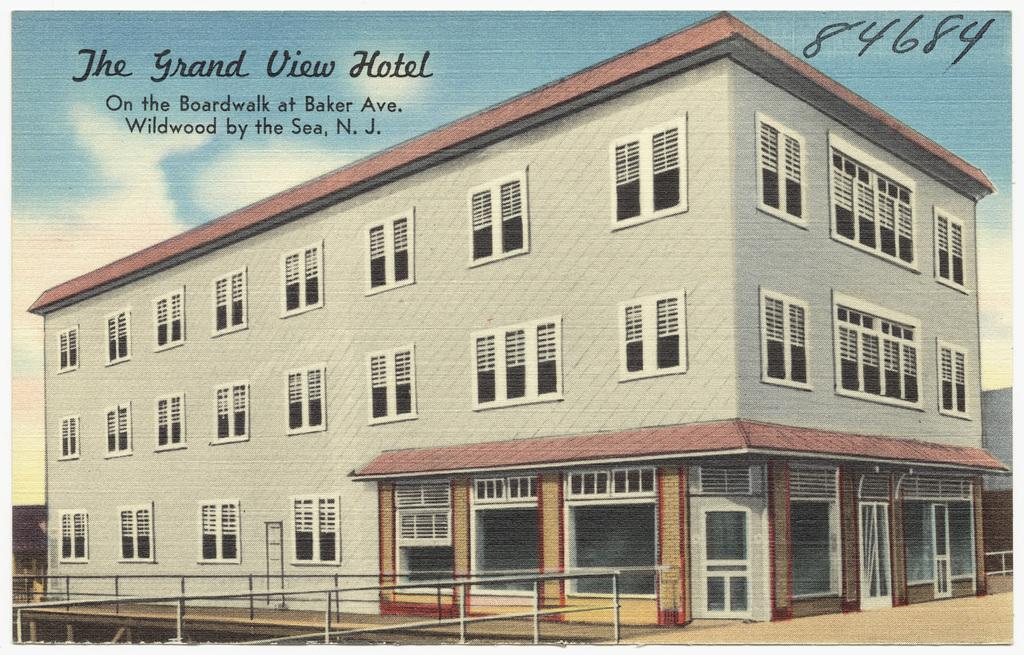What type of image is being described? The image is animated. What can be seen in the image besides the animated elements? There is fencing and a building in the image. What is the color of the sky in the image? The sky is blue in the image. Are there any weather elements visible in the sky? Yes, clouds are visible in the sky. What is written at the top of the image? Text and numbers are written at the top of the image. Where is the locket hanging in the image? There is no locket present in the image. How does the dust affect the visibility of the animated elements in the image? There is no dust present in the image, so it does not affect the visibility of the animated elements. 